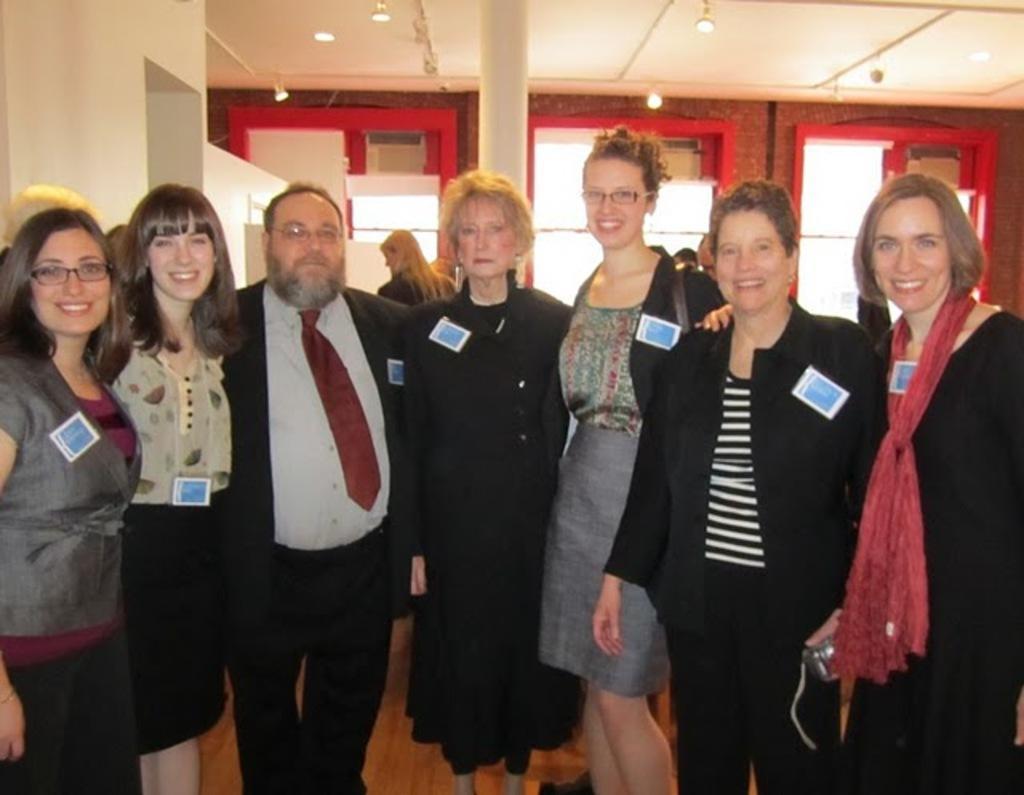Please provide a concise description of this image. In the foreground I can see a group of people are standing on the floor. In the background I can see a wall, doors, pillar and a rooftop. This image is taken in a hall. 